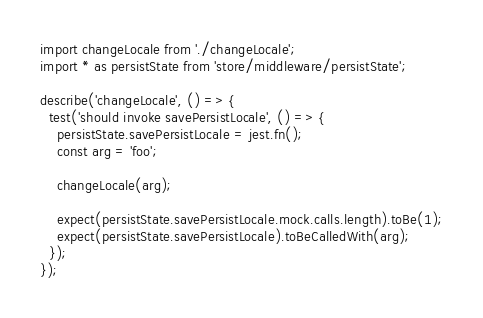<code> <loc_0><loc_0><loc_500><loc_500><_JavaScript_>import changeLocale from './changeLocale';
import * as persistState from 'store/middleware/persistState';

describe('changeLocale', () => {
  test('should invoke savePersistLocale', () => {
    persistState.savePersistLocale = jest.fn();
    const arg = 'foo';

    changeLocale(arg);

    expect(persistState.savePersistLocale.mock.calls.length).toBe(1);
    expect(persistState.savePersistLocale).toBeCalledWith(arg);
  });
});
</code> 